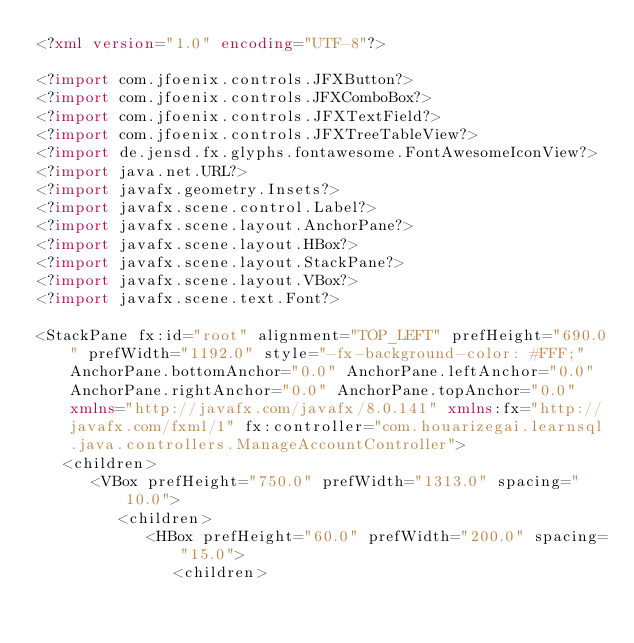<code> <loc_0><loc_0><loc_500><loc_500><_XML_><?xml version="1.0" encoding="UTF-8"?>

<?import com.jfoenix.controls.JFXButton?>
<?import com.jfoenix.controls.JFXComboBox?>
<?import com.jfoenix.controls.JFXTextField?>
<?import com.jfoenix.controls.JFXTreeTableView?>
<?import de.jensd.fx.glyphs.fontawesome.FontAwesomeIconView?>
<?import java.net.URL?>
<?import javafx.geometry.Insets?>
<?import javafx.scene.control.Label?>
<?import javafx.scene.layout.AnchorPane?>
<?import javafx.scene.layout.HBox?>
<?import javafx.scene.layout.StackPane?>
<?import javafx.scene.layout.VBox?>
<?import javafx.scene.text.Font?>

<StackPane fx:id="root" alignment="TOP_LEFT" prefHeight="690.0" prefWidth="1192.0" style="-fx-background-color: #FFF;" AnchorPane.bottomAnchor="0.0" AnchorPane.leftAnchor="0.0" AnchorPane.rightAnchor="0.0" AnchorPane.topAnchor="0.0" xmlns="http://javafx.com/javafx/8.0.141" xmlns:fx="http://javafx.com/fxml/1" fx:controller="com.houarizegai.learnsql.java.controllers.ManageAccountController">
   <children>
      <VBox prefHeight="750.0" prefWidth="1313.0" spacing="10.0">
         <children>
            <HBox prefHeight="60.0" prefWidth="200.0" spacing="15.0">
               <children></code> 